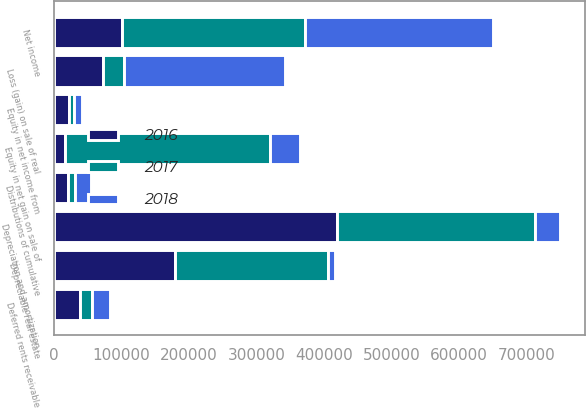Convert chart. <chart><loc_0><loc_0><loc_500><loc_500><stacked_bar_chart><ecel><fcel>Net income<fcel>Depreciation and amortization<fcel>Equity in net income from<fcel>Distributions of cumulative<fcel>Equity in net gain on sale of<fcel>Depreciable real estate<fcel>Loss (gain) on sale of real<fcel>Deferred rents receivable<nl><fcel>2017<fcel>270856<fcel>291915<fcel>7311<fcel>10277<fcel>303967<fcel>227543<fcel>30757<fcel>18216<nl><fcel>2016<fcel>101069<fcel>419818<fcel>21892<fcel>20309<fcel>16166<fcel>178520<fcel>73241<fcel>38009<nl><fcel>2018<fcel>278911<fcel>38009<fcel>11874<fcel>24337<fcel>44009<fcel>10387<fcel>238116<fcel>26716<nl></chart> 